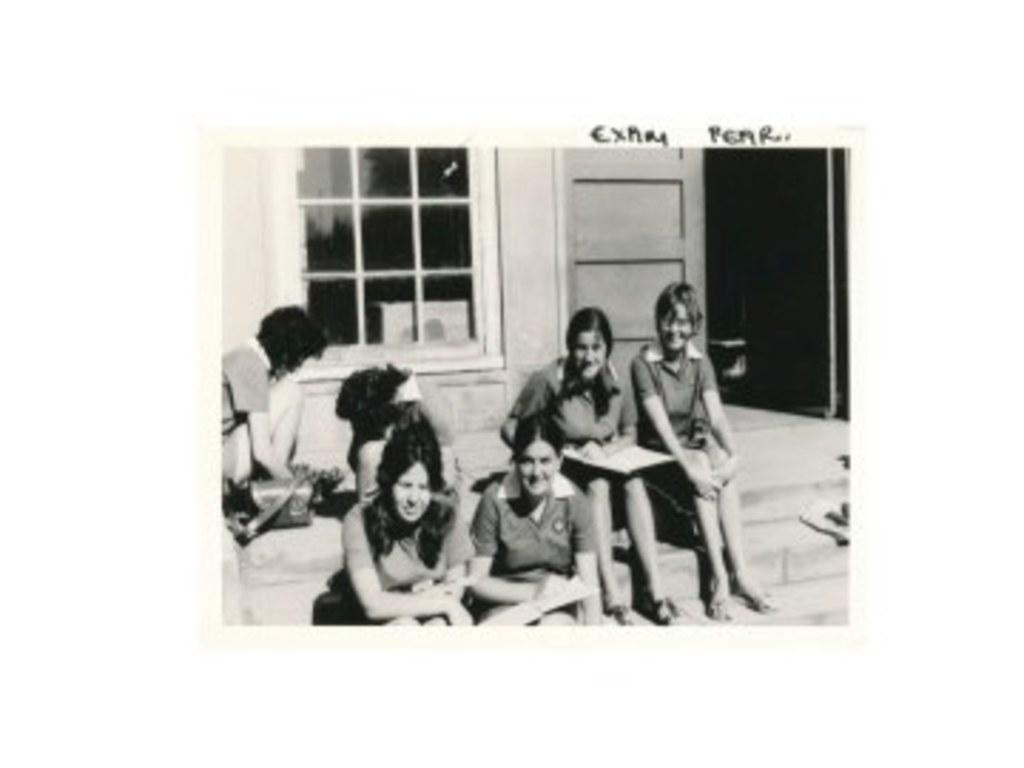Could you give a brief overview of what you see in this image? There are people sitting,background we can see wall,door and window. 